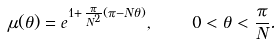Convert formula to latex. <formula><loc_0><loc_0><loc_500><loc_500>\mu ( \theta ) = e ^ { 1 + \, \frac { \pi } { N ^ { 2 } } ( \pi - N \theta ) } , \quad 0 < \theta < \frac { \pi } { N } .</formula> 